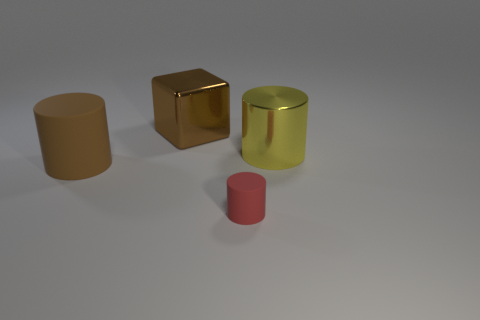Are there any other tiny cylinders that have the same material as the yellow cylinder?
Your response must be concise. No. Is the number of brown things to the right of the yellow thing less than the number of tiny blue rubber blocks?
Provide a succinct answer. No. What material is the cylinder to the left of the metallic object that is to the left of the tiny red thing?
Your answer should be very brief. Rubber. The object that is both behind the small matte thing and right of the large brown metallic block has what shape?
Offer a terse response. Cylinder. What number of other objects are there of the same color as the tiny cylinder?
Provide a succinct answer. 0. What number of things are either brown objects on the left side of the cube or red cylinders?
Provide a succinct answer. 2. There is a big rubber cylinder; is it the same color as the shiny object that is behind the yellow metal cylinder?
Your answer should be very brief. Yes. Is there any other thing that has the same size as the red object?
Your response must be concise. No. How big is the metallic thing right of the big brown thing that is right of the big brown rubber cylinder?
Make the answer very short. Large. What number of objects are either shiny objects or cylinders on the right side of the large brown metal cube?
Ensure brevity in your answer.  3. 